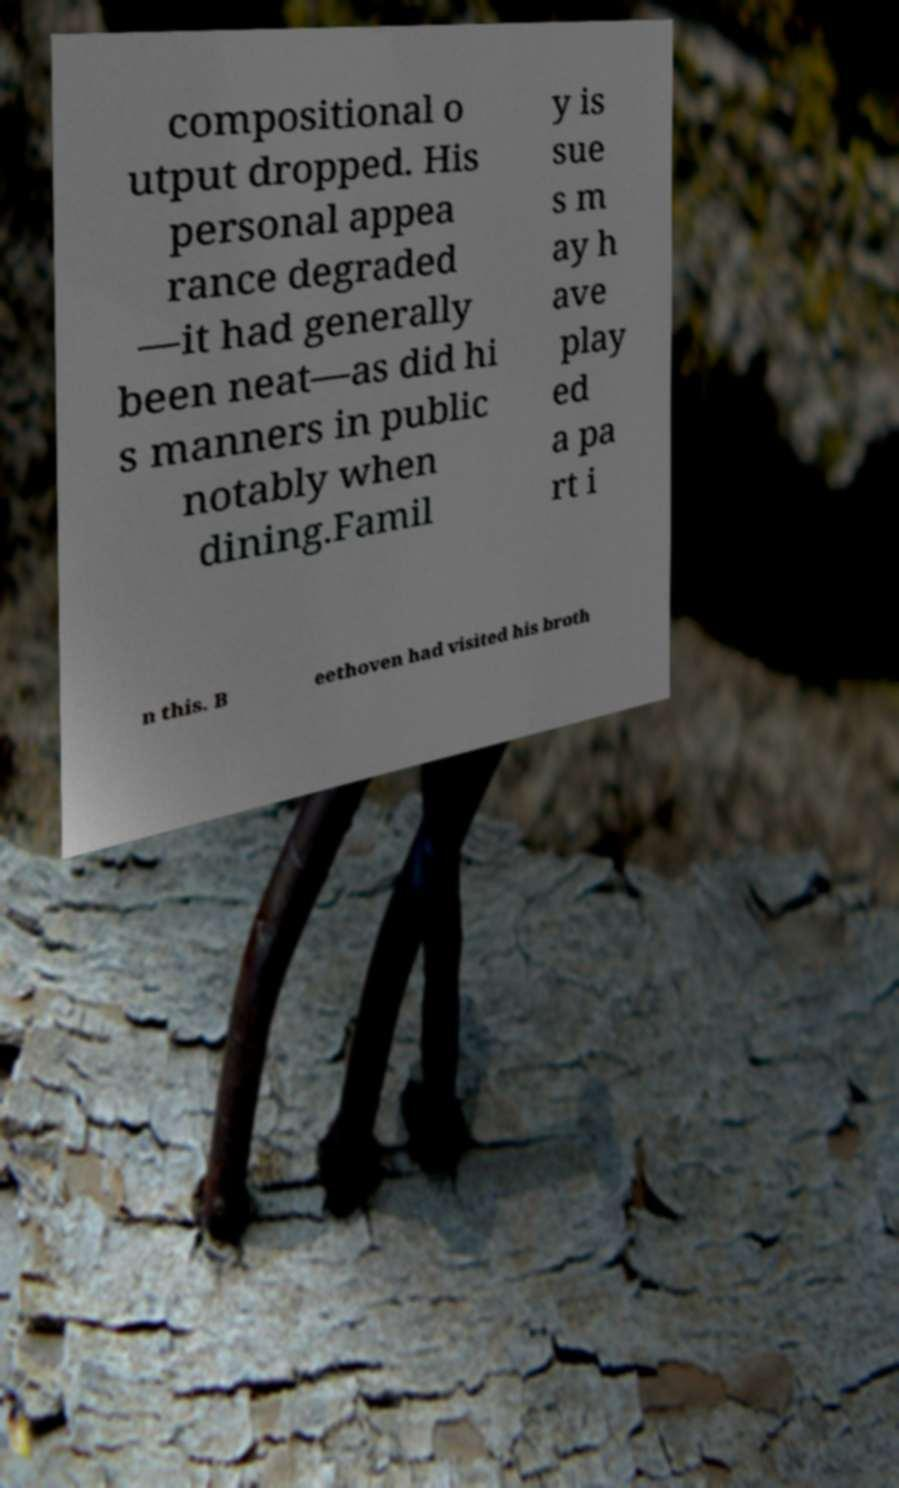For documentation purposes, I need the text within this image transcribed. Could you provide that? compositional o utput dropped. His personal appea rance degraded —it had generally been neat—as did hi s manners in public notably when dining.Famil y is sue s m ay h ave play ed a pa rt i n this. B eethoven had visited his broth 